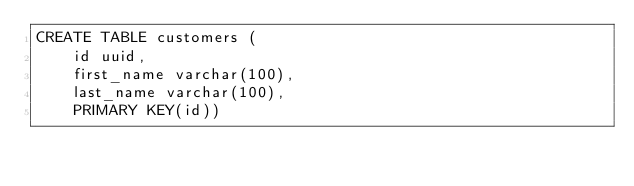<code> <loc_0><loc_0><loc_500><loc_500><_SQL_>CREATE TABLE customers (
    id uuid,
    first_name varchar(100),
    last_name varchar(100),
    PRIMARY KEY(id))</code> 